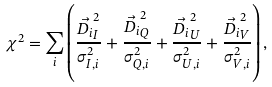Convert formula to latex. <formula><loc_0><loc_0><loc_500><loc_500>\chi ^ { 2 } = \sum _ { i } \left ( \frac { \vec { D _ { i } } _ { I } ^ { 2 } } { \sigma _ { I , i } ^ { 2 } } + \frac { \vec { D _ { i } } _ { Q } ^ { 2 } } { \sigma _ { Q , i } ^ { 2 } } + \frac { \vec { D _ { i } } _ { U } ^ { 2 } } { \sigma _ { U , i } ^ { 2 } } + \frac { \vec { D _ { i } } _ { V } ^ { 2 } } { \sigma _ { V , i } ^ { 2 } } \right ) ,</formula> 